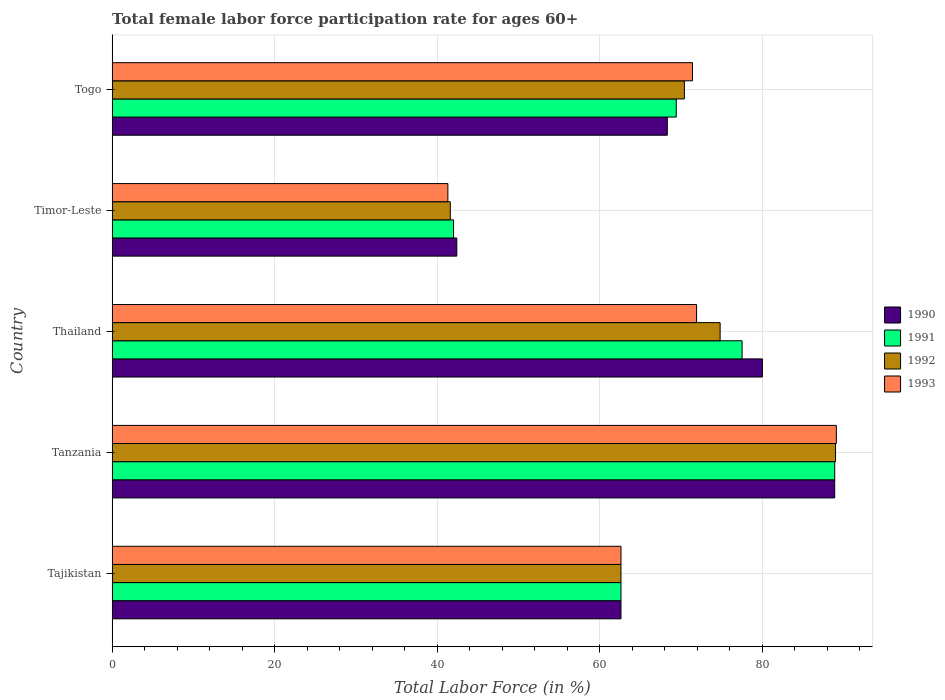How many bars are there on the 4th tick from the bottom?
Keep it short and to the point. 4. What is the label of the 2nd group of bars from the top?
Your response must be concise. Timor-Leste. In how many cases, is the number of bars for a given country not equal to the number of legend labels?
Give a very brief answer. 0. What is the female labor force participation rate in 1992 in Thailand?
Provide a succinct answer. 74.8. Across all countries, what is the maximum female labor force participation rate in 1991?
Provide a short and direct response. 88.9. Across all countries, what is the minimum female labor force participation rate in 1993?
Your answer should be compact. 41.3. In which country was the female labor force participation rate in 1991 maximum?
Provide a short and direct response. Tanzania. In which country was the female labor force participation rate in 1993 minimum?
Make the answer very short. Timor-Leste. What is the total female labor force participation rate in 1993 in the graph?
Your answer should be compact. 336.3. What is the difference between the female labor force participation rate in 1990 in Tajikistan and that in Tanzania?
Ensure brevity in your answer.  -26.3. What is the difference between the female labor force participation rate in 1990 in Togo and the female labor force participation rate in 1992 in Tanzania?
Provide a short and direct response. -20.7. What is the average female labor force participation rate in 1990 per country?
Give a very brief answer. 68.44. What is the difference between the female labor force participation rate in 1992 and female labor force participation rate in 1993 in Tanzania?
Your response must be concise. -0.1. What is the ratio of the female labor force participation rate in 1992 in Tajikistan to that in Tanzania?
Your response must be concise. 0.7. Is the female labor force participation rate in 1992 in Tajikistan less than that in Timor-Leste?
Your answer should be compact. No. What is the difference between the highest and the second highest female labor force participation rate in 1993?
Your answer should be compact. 17.2. What is the difference between the highest and the lowest female labor force participation rate in 1993?
Keep it short and to the point. 47.8. Is the sum of the female labor force participation rate in 1992 in Timor-Leste and Togo greater than the maximum female labor force participation rate in 1990 across all countries?
Provide a succinct answer. Yes. Are all the bars in the graph horizontal?
Ensure brevity in your answer.  Yes. Does the graph contain any zero values?
Ensure brevity in your answer.  No. Does the graph contain grids?
Keep it short and to the point. Yes. What is the title of the graph?
Offer a very short reply. Total female labor force participation rate for ages 60+. Does "2012" appear as one of the legend labels in the graph?
Offer a very short reply. No. What is the label or title of the X-axis?
Provide a short and direct response. Total Labor Force (in %). What is the label or title of the Y-axis?
Your response must be concise. Country. What is the Total Labor Force (in %) of 1990 in Tajikistan?
Your answer should be very brief. 62.6. What is the Total Labor Force (in %) of 1991 in Tajikistan?
Provide a short and direct response. 62.6. What is the Total Labor Force (in %) in 1992 in Tajikistan?
Keep it short and to the point. 62.6. What is the Total Labor Force (in %) of 1993 in Tajikistan?
Provide a succinct answer. 62.6. What is the Total Labor Force (in %) of 1990 in Tanzania?
Offer a terse response. 88.9. What is the Total Labor Force (in %) of 1991 in Tanzania?
Provide a succinct answer. 88.9. What is the Total Labor Force (in %) of 1992 in Tanzania?
Your response must be concise. 89. What is the Total Labor Force (in %) of 1993 in Tanzania?
Make the answer very short. 89.1. What is the Total Labor Force (in %) of 1991 in Thailand?
Your answer should be very brief. 77.5. What is the Total Labor Force (in %) in 1992 in Thailand?
Your response must be concise. 74.8. What is the Total Labor Force (in %) in 1993 in Thailand?
Offer a very short reply. 71.9. What is the Total Labor Force (in %) in 1990 in Timor-Leste?
Ensure brevity in your answer.  42.4. What is the Total Labor Force (in %) of 1991 in Timor-Leste?
Provide a succinct answer. 42. What is the Total Labor Force (in %) in 1992 in Timor-Leste?
Your answer should be very brief. 41.6. What is the Total Labor Force (in %) in 1993 in Timor-Leste?
Your answer should be compact. 41.3. What is the Total Labor Force (in %) of 1990 in Togo?
Offer a terse response. 68.3. What is the Total Labor Force (in %) in 1991 in Togo?
Offer a terse response. 69.4. What is the Total Labor Force (in %) in 1992 in Togo?
Offer a terse response. 70.4. What is the Total Labor Force (in %) of 1993 in Togo?
Your answer should be compact. 71.4. Across all countries, what is the maximum Total Labor Force (in %) of 1990?
Offer a terse response. 88.9. Across all countries, what is the maximum Total Labor Force (in %) in 1991?
Provide a short and direct response. 88.9. Across all countries, what is the maximum Total Labor Force (in %) in 1992?
Your answer should be compact. 89. Across all countries, what is the maximum Total Labor Force (in %) of 1993?
Keep it short and to the point. 89.1. Across all countries, what is the minimum Total Labor Force (in %) of 1990?
Offer a terse response. 42.4. Across all countries, what is the minimum Total Labor Force (in %) of 1992?
Provide a succinct answer. 41.6. Across all countries, what is the minimum Total Labor Force (in %) of 1993?
Offer a terse response. 41.3. What is the total Total Labor Force (in %) of 1990 in the graph?
Ensure brevity in your answer.  342.2. What is the total Total Labor Force (in %) of 1991 in the graph?
Your answer should be compact. 340.4. What is the total Total Labor Force (in %) in 1992 in the graph?
Provide a short and direct response. 338.4. What is the total Total Labor Force (in %) of 1993 in the graph?
Provide a short and direct response. 336.3. What is the difference between the Total Labor Force (in %) of 1990 in Tajikistan and that in Tanzania?
Your response must be concise. -26.3. What is the difference between the Total Labor Force (in %) of 1991 in Tajikistan and that in Tanzania?
Provide a succinct answer. -26.3. What is the difference between the Total Labor Force (in %) in 1992 in Tajikistan and that in Tanzania?
Your response must be concise. -26.4. What is the difference between the Total Labor Force (in %) of 1993 in Tajikistan and that in Tanzania?
Offer a terse response. -26.5. What is the difference between the Total Labor Force (in %) of 1990 in Tajikistan and that in Thailand?
Ensure brevity in your answer.  -17.4. What is the difference between the Total Labor Force (in %) of 1991 in Tajikistan and that in Thailand?
Your response must be concise. -14.9. What is the difference between the Total Labor Force (in %) of 1992 in Tajikistan and that in Thailand?
Your response must be concise. -12.2. What is the difference between the Total Labor Force (in %) in 1993 in Tajikistan and that in Thailand?
Your answer should be very brief. -9.3. What is the difference between the Total Labor Force (in %) in 1990 in Tajikistan and that in Timor-Leste?
Your answer should be very brief. 20.2. What is the difference between the Total Labor Force (in %) in 1991 in Tajikistan and that in Timor-Leste?
Keep it short and to the point. 20.6. What is the difference between the Total Labor Force (in %) in 1993 in Tajikistan and that in Timor-Leste?
Your answer should be compact. 21.3. What is the difference between the Total Labor Force (in %) of 1990 in Tanzania and that in Thailand?
Provide a short and direct response. 8.9. What is the difference between the Total Labor Force (in %) of 1990 in Tanzania and that in Timor-Leste?
Ensure brevity in your answer.  46.5. What is the difference between the Total Labor Force (in %) of 1991 in Tanzania and that in Timor-Leste?
Make the answer very short. 46.9. What is the difference between the Total Labor Force (in %) in 1992 in Tanzania and that in Timor-Leste?
Your response must be concise. 47.4. What is the difference between the Total Labor Force (in %) in 1993 in Tanzania and that in Timor-Leste?
Provide a short and direct response. 47.8. What is the difference between the Total Labor Force (in %) of 1990 in Tanzania and that in Togo?
Offer a terse response. 20.6. What is the difference between the Total Labor Force (in %) of 1990 in Thailand and that in Timor-Leste?
Make the answer very short. 37.6. What is the difference between the Total Labor Force (in %) in 1991 in Thailand and that in Timor-Leste?
Provide a succinct answer. 35.5. What is the difference between the Total Labor Force (in %) in 1992 in Thailand and that in Timor-Leste?
Offer a very short reply. 33.2. What is the difference between the Total Labor Force (in %) in 1993 in Thailand and that in Timor-Leste?
Your answer should be compact. 30.6. What is the difference between the Total Labor Force (in %) in 1990 in Thailand and that in Togo?
Your answer should be very brief. 11.7. What is the difference between the Total Labor Force (in %) of 1992 in Thailand and that in Togo?
Provide a short and direct response. 4.4. What is the difference between the Total Labor Force (in %) in 1990 in Timor-Leste and that in Togo?
Your answer should be very brief. -25.9. What is the difference between the Total Labor Force (in %) in 1991 in Timor-Leste and that in Togo?
Make the answer very short. -27.4. What is the difference between the Total Labor Force (in %) in 1992 in Timor-Leste and that in Togo?
Your answer should be very brief. -28.8. What is the difference between the Total Labor Force (in %) in 1993 in Timor-Leste and that in Togo?
Offer a terse response. -30.1. What is the difference between the Total Labor Force (in %) of 1990 in Tajikistan and the Total Labor Force (in %) of 1991 in Tanzania?
Make the answer very short. -26.3. What is the difference between the Total Labor Force (in %) in 1990 in Tajikistan and the Total Labor Force (in %) in 1992 in Tanzania?
Provide a succinct answer. -26.4. What is the difference between the Total Labor Force (in %) in 1990 in Tajikistan and the Total Labor Force (in %) in 1993 in Tanzania?
Keep it short and to the point. -26.5. What is the difference between the Total Labor Force (in %) of 1991 in Tajikistan and the Total Labor Force (in %) of 1992 in Tanzania?
Keep it short and to the point. -26.4. What is the difference between the Total Labor Force (in %) of 1991 in Tajikistan and the Total Labor Force (in %) of 1993 in Tanzania?
Provide a succinct answer. -26.5. What is the difference between the Total Labor Force (in %) of 1992 in Tajikistan and the Total Labor Force (in %) of 1993 in Tanzania?
Your answer should be compact. -26.5. What is the difference between the Total Labor Force (in %) in 1990 in Tajikistan and the Total Labor Force (in %) in 1991 in Thailand?
Give a very brief answer. -14.9. What is the difference between the Total Labor Force (in %) of 1991 in Tajikistan and the Total Labor Force (in %) of 1992 in Thailand?
Your response must be concise. -12.2. What is the difference between the Total Labor Force (in %) of 1991 in Tajikistan and the Total Labor Force (in %) of 1993 in Thailand?
Ensure brevity in your answer.  -9.3. What is the difference between the Total Labor Force (in %) in 1990 in Tajikistan and the Total Labor Force (in %) in 1991 in Timor-Leste?
Ensure brevity in your answer.  20.6. What is the difference between the Total Labor Force (in %) in 1990 in Tajikistan and the Total Labor Force (in %) in 1993 in Timor-Leste?
Offer a terse response. 21.3. What is the difference between the Total Labor Force (in %) in 1991 in Tajikistan and the Total Labor Force (in %) in 1993 in Timor-Leste?
Offer a terse response. 21.3. What is the difference between the Total Labor Force (in %) in 1992 in Tajikistan and the Total Labor Force (in %) in 1993 in Timor-Leste?
Keep it short and to the point. 21.3. What is the difference between the Total Labor Force (in %) of 1990 in Tajikistan and the Total Labor Force (in %) of 1991 in Togo?
Offer a terse response. -6.8. What is the difference between the Total Labor Force (in %) in 1990 in Tajikistan and the Total Labor Force (in %) in 1992 in Togo?
Make the answer very short. -7.8. What is the difference between the Total Labor Force (in %) in 1990 in Tajikistan and the Total Labor Force (in %) in 1993 in Togo?
Ensure brevity in your answer.  -8.8. What is the difference between the Total Labor Force (in %) in 1990 in Tanzania and the Total Labor Force (in %) in 1991 in Thailand?
Ensure brevity in your answer.  11.4. What is the difference between the Total Labor Force (in %) in 1991 in Tanzania and the Total Labor Force (in %) in 1993 in Thailand?
Your response must be concise. 17. What is the difference between the Total Labor Force (in %) in 1992 in Tanzania and the Total Labor Force (in %) in 1993 in Thailand?
Your answer should be very brief. 17.1. What is the difference between the Total Labor Force (in %) in 1990 in Tanzania and the Total Labor Force (in %) in 1991 in Timor-Leste?
Your response must be concise. 46.9. What is the difference between the Total Labor Force (in %) of 1990 in Tanzania and the Total Labor Force (in %) of 1992 in Timor-Leste?
Offer a terse response. 47.3. What is the difference between the Total Labor Force (in %) of 1990 in Tanzania and the Total Labor Force (in %) of 1993 in Timor-Leste?
Keep it short and to the point. 47.6. What is the difference between the Total Labor Force (in %) in 1991 in Tanzania and the Total Labor Force (in %) in 1992 in Timor-Leste?
Ensure brevity in your answer.  47.3. What is the difference between the Total Labor Force (in %) in 1991 in Tanzania and the Total Labor Force (in %) in 1993 in Timor-Leste?
Provide a short and direct response. 47.6. What is the difference between the Total Labor Force (in %) of 1992 in Tanzania and the Total Labor Force (in %) of 1993 in Timor-Leste?
Ensure brevity in your answer.  47.7. What is the difference between the Total Labor Force (in %) of 1990 in Tanzania and the Total Labor Force (in %) of 1991 in Togo?
Keep it short and to the point. 19.5. What is the difference between the Total Labor Force (in %) in 1991 in Tanzania and the Total Labor Force (in %) in 1993 in Togo?
Keep it short and to the point. 17.5. What is the difference between the Total Labor Force (in %) of 1992 in Tanzania and the Total Labor Force (in %) of 1993 in Togo?
Make the answer very short. 17.6. What is the difference between the Total Labor Force (in %) in 1990 in Thailand and the Total Labor Force (in %) in 1991 in Timor-Leste?
Give a very brief answer. 38. What is the difference between the Total Labor Force (in %) in 1990 in Thailand and the Total Labor Force (in %) in 1992 in Timor-Leste?
Offer a terse response. 38.4. What is the difference between the Total Labor Force (in %) of 1990 in Thailand and the Total Labor Force (in %) of 1993 in Timor-Leste?
Offer a terse response. 38.7. What is the difference between the Total Labor Force (in %) of 1991 in Thailand and the Total Labor Force (in %) of 1992 in Timor-Leste?
Your answer should be compact. 35.9. What is the difference between the Total Labor Force (in %) of 1991 in Thailand and the Total Labor Force (in %) of 1993 in Timor-Leste?
Keep it short and to the point. 36.2. What is the difference between the Total Labor Force (in %) of 1992 in Thailand and the Total Labor Force (in %) of 1993 in Timor-Leste?
Provide a succinct answer. 33.5. What is the difference between the Total Labor Force (in %) in 1990 in Thailand and the Total Labor Force (in %) in 1993 in Togo?
Make the answer very short. 8.6. What is the difference between the Total Labor Force (in %) in 1991 in Thailand and the Total Labor Force (in %) in 1992 in Togo?
Provide a short and direct response. 7.1. What is the difference between the Total Labor Force (in %) of 1991 in Thailand and the Total Labor Force (in %) of 1993 in Togo?
Offer a very short reply. 6.1. What is the difference between the Total Labor Force (in %) of 1992 in Thailand and the Total Labor Force (in %) of 1993 in Togo?
Offer a very short reply. 3.4. What is the difference between the Total Labor Force (in %) in 1991 in Timor-Leste and the Total Labor Force (in %) in 1992 in Togo?
Make the answer very short. -28.4. What is the difference between the Total Labor Force (in %) of 1991 in Timor-Leste and the Total Labor Force (in %) of 1993 in Togo?
Keep it short and to the point. -29.4. What is the difference between the Total Labor Force (in %) of 1992 in Timor-Leste and the Total Labor Force (in %) of 1993 in Togo?
Your answer should be compact. -29.8. What is the average Total Labor Force (in %) in 1990 per country?
Give a very brief answer. 68.44. What is the average Total Labor Force (in %) in 1991 per country?
Your answer should be compact. 68.08. What is the average Total Labor Force (in %) of 1992 per country?
Your answer should be compact. 67.68. What is the average Total Labor Force (in %) in 1993 per country?
Your answer should be compact. 67.26. What is the difference between the Total Labor Force (in %) in 1990 and Total Labor Force (in %) in 1992 in Tajikistan?
Your response must be concise. 0. What is the difference between the Total Labor Force (in %) in 1992 and Total Labor Force (in %) in 1993 in Tajikistan?
Offer a very short reply. 0. What is the difference between the Total Labor Force (in %) of 1990 and Total Labor Force (in %) of 1992 in Tanzania?
Give a very brief answer. -0.1. What is the difference between the Total Labor Force (in %) in 1991 and Total Labor Force (in %) in 1992 in Tanzania?
Provide a short and direct response. -0.1. What is the difference between the Total Labor Force (in %) in 1991 and Total Labor Force (in %) in 1993 in Tanzania?
Provide a succinct answer. -0.2. What is the difference between the Total Labor Force (in %) in 1992 and Total Labor Force (in %) in 1993 in Tanzania?
Ensure brevity in your answer.  -0.1. What is the difference between the Total Labor Force (in %) of 1990 and Total Labor Force (in %) of 1992 in Thailand?
Your response must be concise. 5.2. What is the difference between the Total Labor Force (in %) of 1991 and Total Labor Force (in %) of 1992 in Thailand?
Make the answer very short. 2.7. What is the difference between the Total Labor Force (in %) in 1991 and Total Labor Force (in %) in 1993 in Thailand?
Provide a succinct answer. 5.6. What is the difference between the Total Labor Force (in %) in 1992 and Total Labor Force (in %) in 1993 in Thailand?
Your answer should be compact. 2.9. What is the difference between the Total Labor Force (in %) in 1990 and Total Labor Force (in %) in 1991 in Timor-Leste?
Keep it short and to the point. 0.4. What is the difference between the Total Labor Force (in %) of 1990 and Total Labor Force (in %) of 1993 in Timor-Leste?
Your answer should be very brief. 1.1. What is the difference between the Total Labor Force (in %) in 1991 and Total Labor Force (in %) in 1992 in Timor-Leste?
Offer a very short reply. 0.4. What is the difference between the Total Labor Force (in %) of 1990 and Total Labor Force (in %) of 1992 in Togo?
Provide a short and direct response. -2.1. What is the difference between the Total Labor Force (in %) in 1991 and Total Labor Force (in %) in 1992 in Togo?
Provide a succinct answer. -1. What is the difference between the Total Labor Force (in %) in 1992 and Total Labor Force (in %) in 1993 in Togo?
Provide a succinct answer. -1. What is the ratio of the Total Labor Force (in %) in 1990 in Tajikistan to that in Tanzania?
Provide a succinct answer. 0.7. What is the ratio of the Total Labor Force (in %) of 1991 in Tajikistan to that in Tanzania?
Give a very brief answer. 0.7. What is the ratio of the Total Labor Force (in %) in 1992 in Tajikistan to that in Tanzania?
Provide a succinct answer. 0.7. What is the ratio of the Total Labor Force (in %) of 1993 in Tajikistan to that in Tanzania?
Provide a short and direct response. 0.7. What is the ratio of the Total Labor Force (in %) of 1990 in Tajikistan to that in Thailand?
Provide a short and direct response. 0.78. What is the ratio of the Total Labor Force (in %) in 1991 in Tajikistan to that in Thailand?
Your answer should be compact. 0.81. What is the ratio of the Total Labor Force (in %) in 1992 in Tajikistan to that in Thailand?
Ensure brevity in your answer.  0.84. What is the ratio of the Total Labor Force (in %) of 1993 in Tajikistan to that in Thailand?
Your answer should be very brief. 0.87. What is the ratio of the Total Labor Force (in %) in 1990 in Tajikistan to that in Timor-Leste?
Provide a short and direct response. 1.48. What is the ratio of the Total Labor Force (in %) in 1991 in Tajikistan to that in Timor-Leste?
Your answer should be very brief. 1.49. What is the ratio of the Total Labor Force (in %) of 1992 in Tajikistan to that in Timor-Leste?
Provide a short and direct response. 1.5. What is the ratio of the Total Labor Force (in %) of 1993 in Tajikistan to that in Timor-Leste?
Your response must be concise. 1.52. What is the ratio of the Total Labor Force (in %) in 1990 in Tajikistan to that in Togo?
Offer a very short reply. 0.92. What is the ratio of the Total Labor Force (in %) in 1991 in Tajikistan to that in Togo?
Make the answer very short. 0.9. What is the ratio of the Total Labor Force (in %) in 1992 in Tajikistan to that in Togo?
Provide a short and direct response. 0.89. What is the ratio of the Total Labor Force (in %) of 1993 in Tajikistan to that in Togo?
Make the answer very short. 0.88. What is the ratio of the Total Labor Force (in %) of 1990 in Tanzania to that in Thailand?
Keep it short and to the point. 1.11. What is the ratio of the Total Labor Force (in %) in 1991 in Tanzania to that in Thailand?
Ensure brevity in your answer.  1.15. What is the ratio of the Total Labor Force (in %) in 1992 in Tanzania to that in Thailand?
Ensure brevity in your answer.  1.19. What is the ratio of the Total Labor Force (in %) of 1993 in Tanzania to that in Thailand?
Give a very brief answer. 1.24. What is the ratio of the Total Labor Force (in %) in 1990 in Tanzania to that in Timor-Leste?
Offer a very short reply. 2.1. What is the ratio of the Total Labor Force (in %) in 1991 in Tanzania to that in Timor-Leste?
Give a very brief answer. 2.12. What is the ratio of the Total Labor Force (in %) of 1992 in Tanzania to that in Timor-Leste?
Your response must be concise. 2.14. What is the ratio of the Total Labor Force (in %) in 1993 in Tanzania to that in Timor-Leste?
Offer a terse response. 2.16. What is the ratio of the Total Labor Force (in %) in 1990 in Tanzania to that in Togo?
Your response must be concise. 1.3. What is the ratio of the Total Labor Force (in %) of 1991 in Tanzania to that in Togo?
Your answer should be compact. 1.28. What is the ratio of the Total Labor Force (in %) in 1992 in Tanzania to that in Togo?
Give a very brief answer. 1.26. What is the ratio of the Total Labor Force (in %) of 1993 in Tanzania to that in Togo?
Your answer should be compact. 1.25. What is the ratio of the Total Labor Force (in %) in 1990 in Thailand to that in Timor-Leste?
Provide a short and direct response. 1.89. What is the ratio of the Total Labor Force (in %) of 1991 in Thailand to that in Timor-Leste?
Your answer should be compact. 1.85. What is the ratio of the Total Labor Force (in %) of 1992 in Thailand to that in Timor-Leste?
Your response must be concise. 1.8. What is the ratio of the Total Labor Force (in %) in 1993 in Thailand to that in Timor-Leste?
Your answer should be compact. 1.74. What is the ratio of the Total Labor Force (in %) in 1990 in Thailand to that in Togo?
Your answer should be compact. 1.17. What is the ratio of the Total Labor Force (in %) of 1991 in Thailand to that in Togo?
Offer a terse response. 1.12. What is the ratio of the Total Labor Force (in %) in 1990 in Timor-Leste to that in Togo?
Your response must be concise. 0.62. What is the ratio of the Total Labor Force (in %) of 1991 in Timor-Leste to that in Togo?
Your response must be concise. 0.61. What is the ratio of the Total Labor Force (in %) of 1992 in Timor-Leste to that in Togo?
Give a very brief answer. 0.59. What is the ratio of the Total Labor Force (in %) of 1993 in Timor-Leste to that in Togo?
Offer a terse response. 0.58. What is the difference between the highest and the second highest Total Labor Force (in %) in 1990?
Provide a short and direct response. 8.9. What is the difference between the highest and the second highest Total Labor Force (in %) in 1993?
Ensure brevity in your answer.  17.2. What is the difference between the highest and the lowest Total Labor Force (in %) of 1990?
Offer a very short reply. 46.5. What is the difference between the highest and the lowest Total Labor Force (in %) in 1991?
Offer a terse response. 46.9. What is the difference between the highest and the lowest Total Labor Force (in %) in 1992?
Your answer should be compact. 47.4. What is the difference between the highest and the lowest Total Labor Force (in %) of 1993?
Make the answer very short. 47.8. 